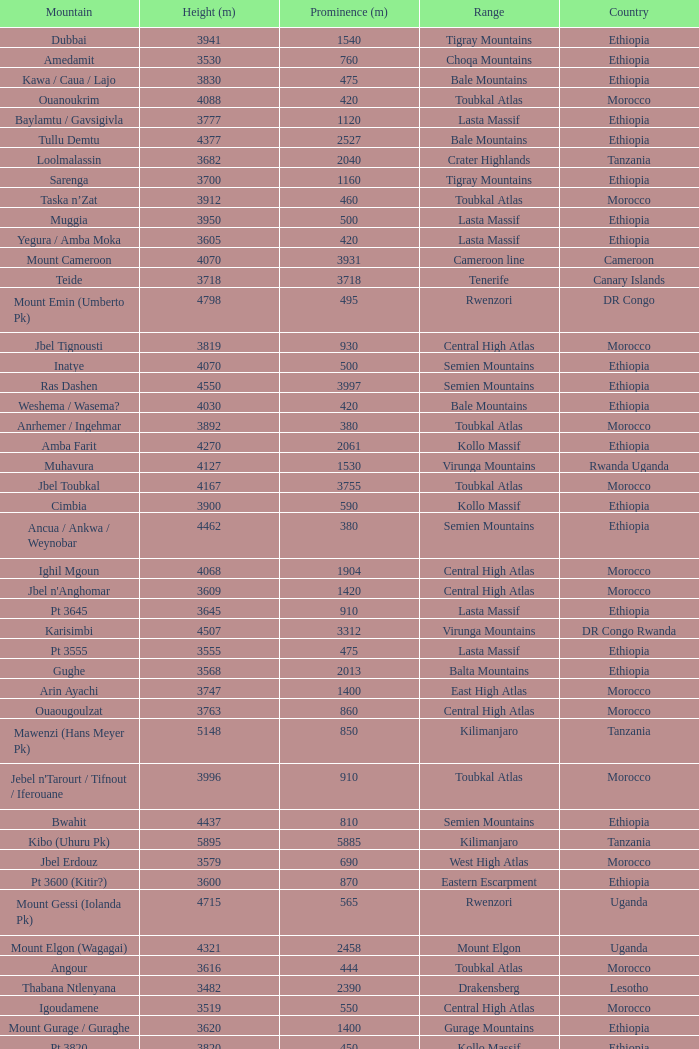How tall is the Mountain of jbel ghat? 1.0. 